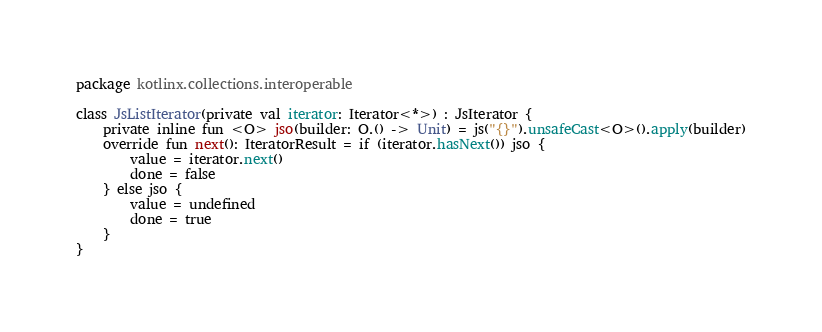Convert code to text. <code><loc_0><loc_0><loc_500><loc_500><_Kotlin_>package kotlinx.collections.interoperable

class JsListIterator(private val iterator: Iterator<*>) : JsIterator {
    private inline fun <O> jso(builder: O.() -> Unit) = js("{}").unsafeCast<O>().apply(builder)
    override fun next(): IteratorResult = if (iterator.hasNext()) jso {
        value = iterator.next()
        done = false
    } else jso {
        value = undefined
        done = true
    }
}</code> 